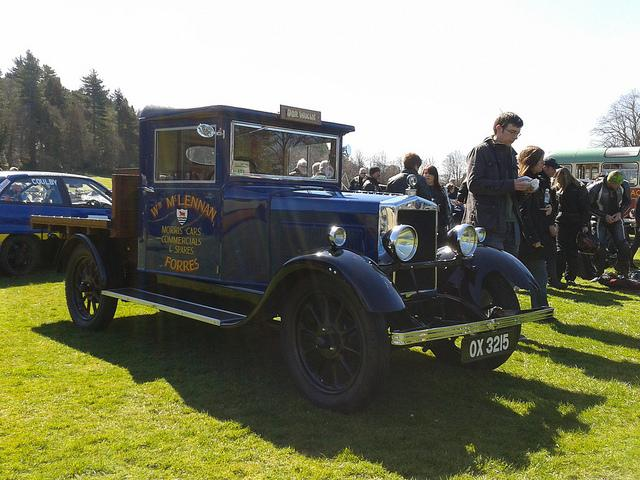What type of truck is shown? flatbed 